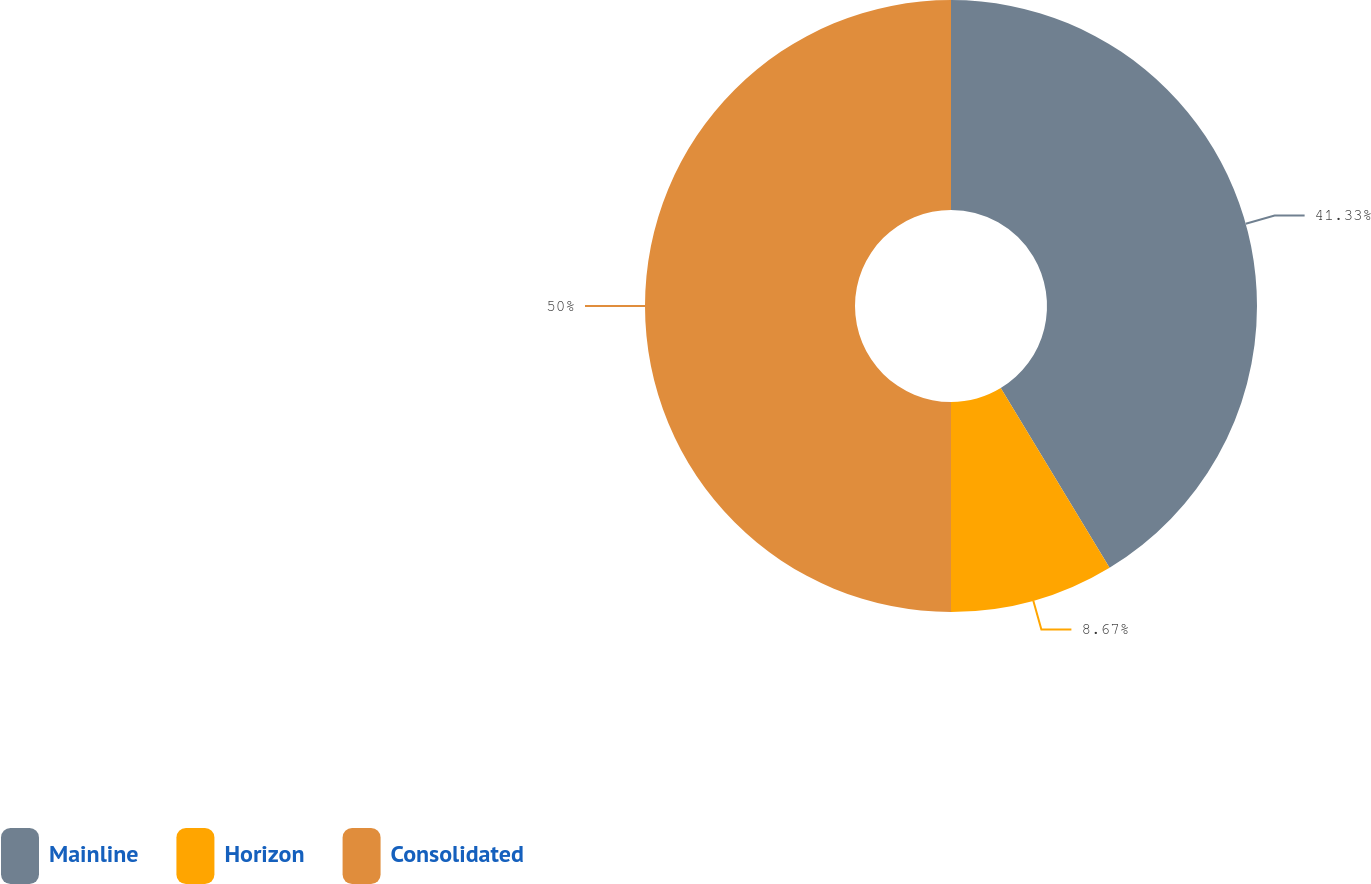<chart> <loc_0><loc_0><loc_500><loc_500><pie_chart><fcel>Mainline<fcel>Horizon<fcel>Consolidated<nl><fcel>41.33%<fcel>8.67%<fcel>50.0%<nl></chart> 